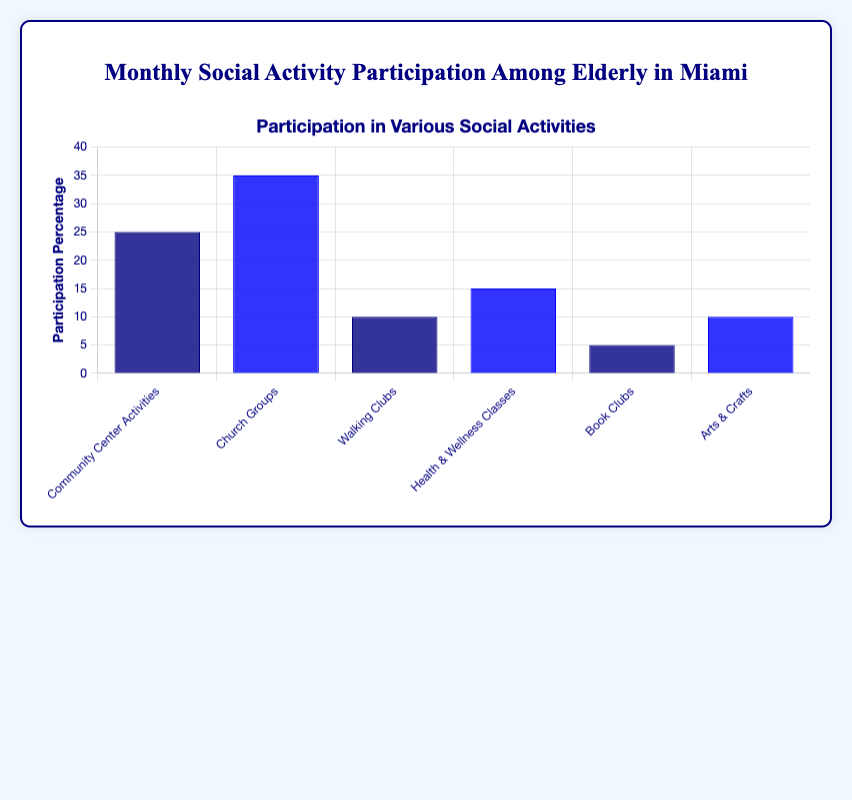Which activity has the highest participation percentage? The figure shows that "Church Groups" has the tallest bar, representing the highest participation percentage.
Answer: Church Groups How much higher is the participation percentage in Church Groups compared to Walking Clubs? The participation percentage for Church Groups is 35%, while for Walking Clubs it is 10%. Subtracting 10% from 35% gives us the difference.
Answer: 25% Which two activities have the same participation percentage? The bars for "Walking Clubs" and "Arts & Crafts" are of equal height, indicating the same participation percentage for these activities.
Answer: Walking Clubs and Arts & Crafts What is the total participation percentage of all activities combined? Add the participation percentages of all activities: 25% (Community Center Activities) + 35% (Church Groups) + 10% (Walking Clubs) + 15% (Health & Wellness Classes) + 5% (Book Clubs) + 10% (Arts & Crafts) = 100%.
Answer: 100% Which activity's bar is colored dark blue and represents a 25% participation? The figure uses dark blue for activities, and the bar with 25% participation represents "Community Center Activities."
Answer: Community Center Activities What is the average participation percentage across all activities? Sum the participation percentages and divide by the number of activities: (25% + 35% + 10% + 15% + 5% + 10%) / 6 = 100% / 6.
Answer: Approximately 16.67% What is the combined participation percentage of Book Clubs and Health & Wellness Classes? Add the participation percentages of Book Clubs (5%) and Health & Wellness Classes (15%): 5% + 15%.
Answer: 20% Which activities have participation percentages less than 15%? The bars representing "Walking Clubs" (10%), "Book Clubs" (5%), and "Arts & Crafts" (10%) are below 15%.
Answer: Walking Clubs, Book Clubs, Arts & Crafts How much lower is the participation percentage for Arts & Crafts compared to Community Center Activities? The participation for Community Center Activities is 25%, while for Arts & Crafts it is 10%. Subtracting 10% from 25% gives us the difference.
Answer: 15% What is the participation percentage difference between the highest and lowest activity? The highest participation percentage is for Church Groups (35%) and the lowest is for Book Clubs (5%). Subtract 5% from 35%.
Answer: 30% 